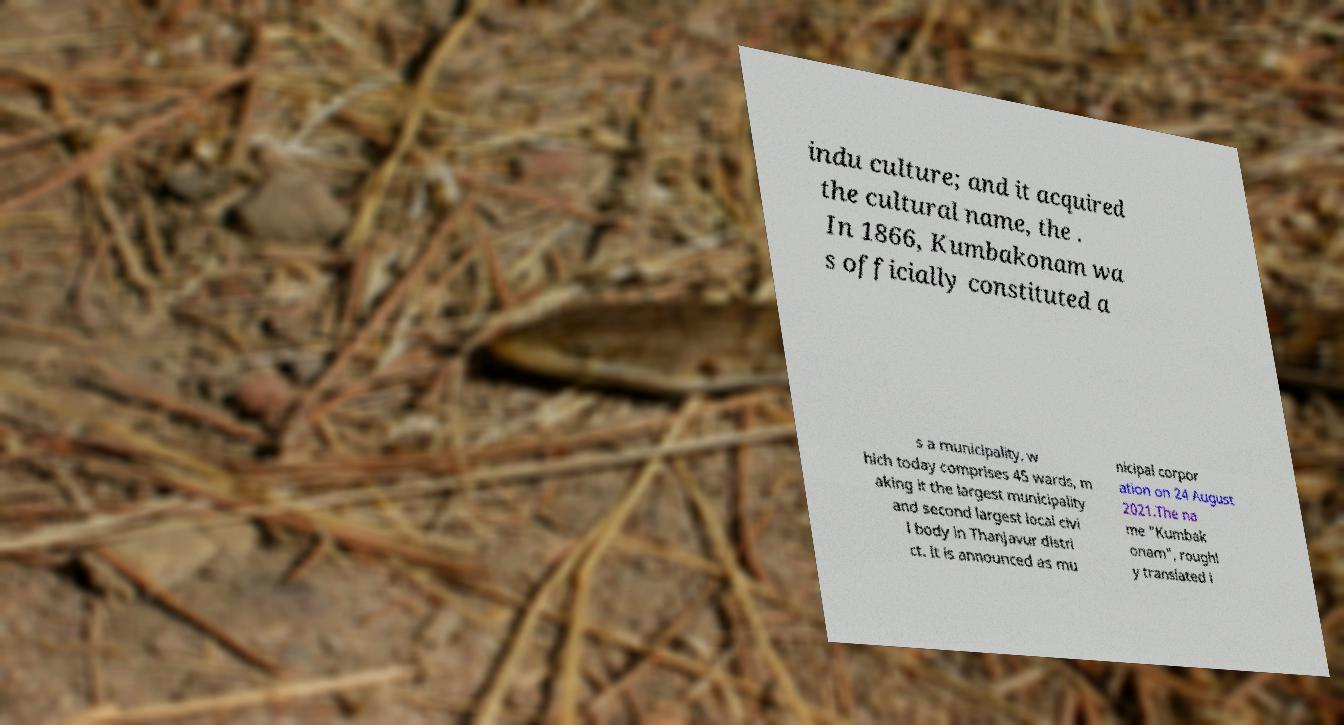For documentation purposes, I need the text within this image transcribed. Could you provide that? indu culture; and it acquired the cultural name, the . In 1866, Kumbakonam wa s officially constituted a s a municipality, w hich today comprises 45 wards, m aking it the largest municipality and second largest local civi l body in Thanjavur distri ct. It is announced as mu nicipal corpor ation on 24 August 2021.The na me "Kumbak onam", roughl y translated i 